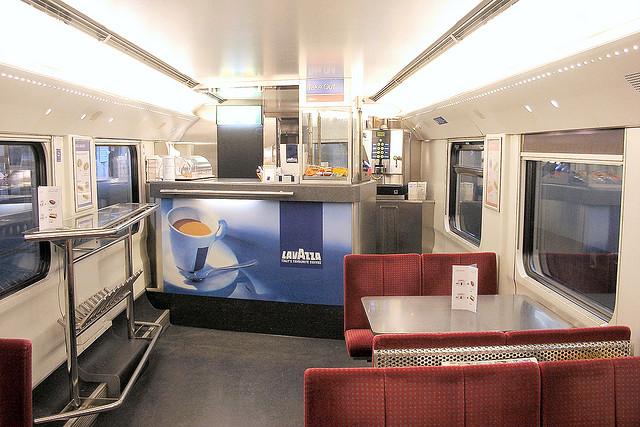What brand of coffee is featured in the advertisement?
Be succinct. Lavazza. Is the light natural or not?
Answer briefly. No. Where is this room?
Quick response, please. Train. 